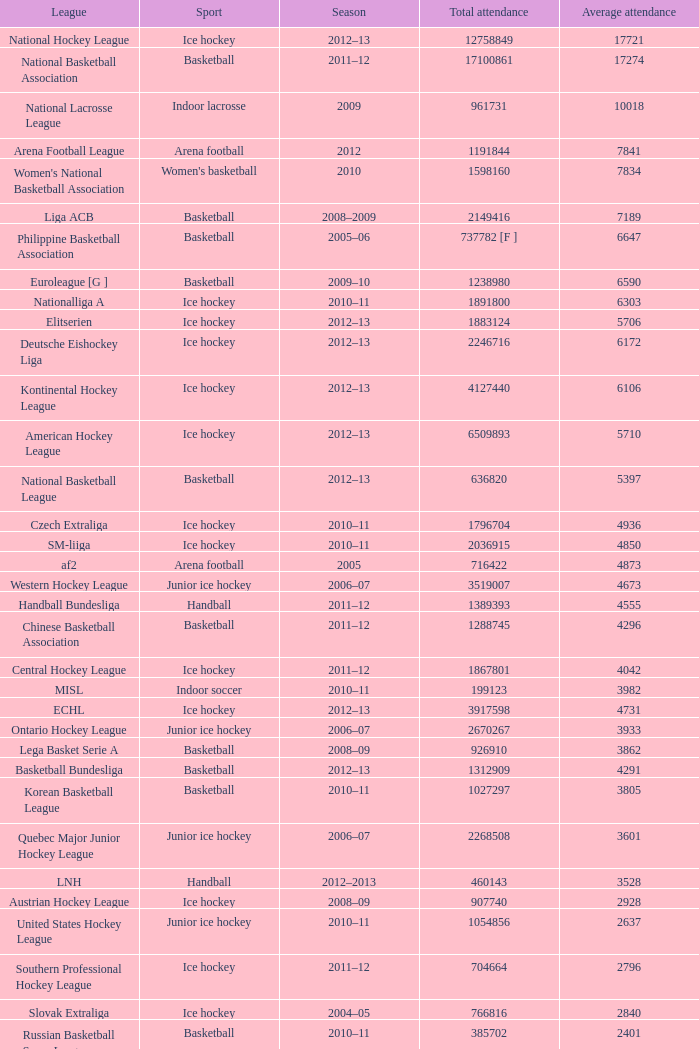What's the average attendance of the league with a total attendance of 2268508? 3601.0. 